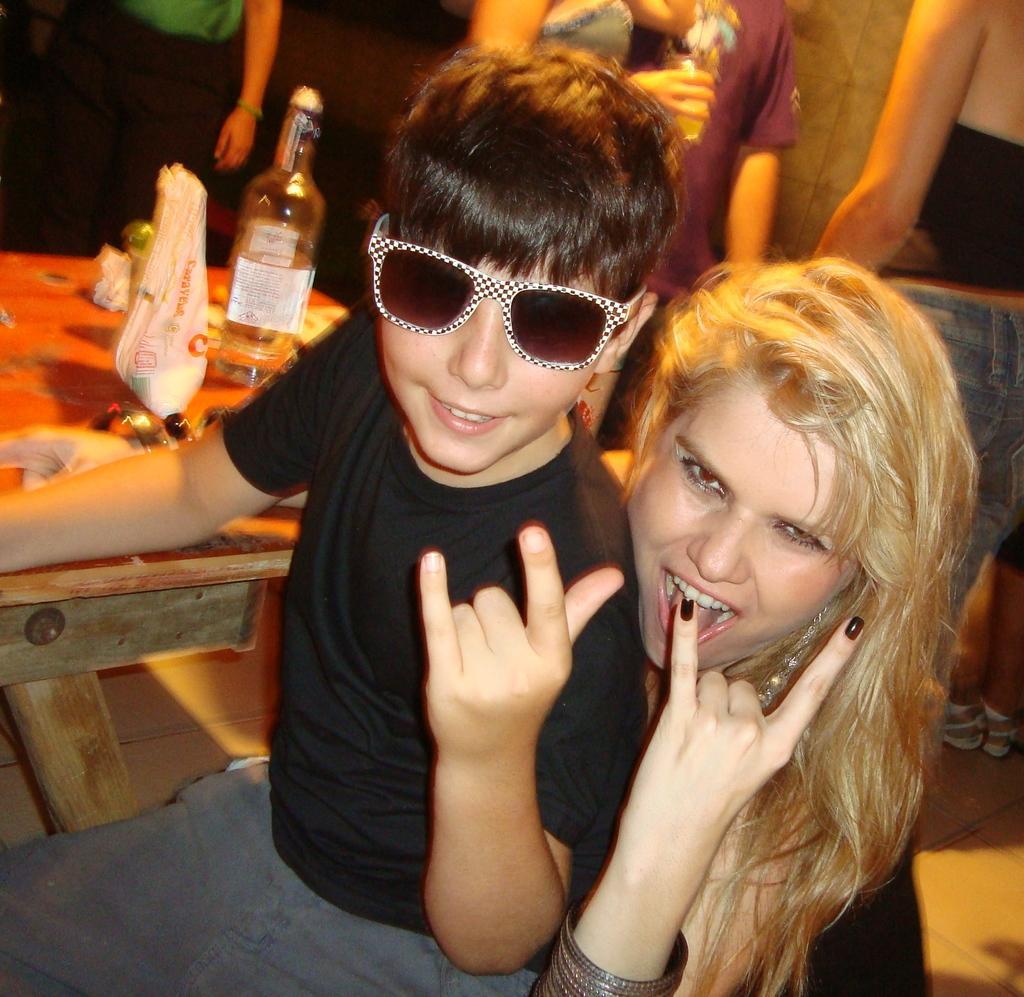Describe this image in one or two sentences. There is a lady and a boy. Boy is wearing a goggles. In the back there is a table. On the table there is a bottle and some other items. In the back some people are there. 